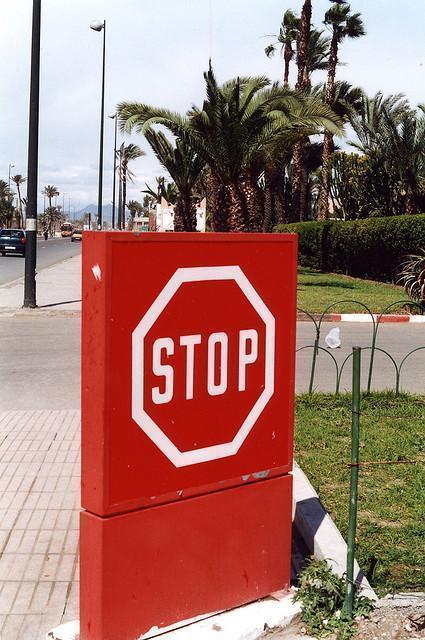Where can we find the sign above?
Make your selection from the four choices given to correctly answer the question.
Options: Kitchen, ocean, road, home. Road. 